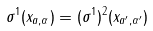<formula> <loc_0><loc_0><loc_500><loc_500>\sigma ^ { 1 } ( x _ { a , \alpha } ) = ( \sigma ^ { 1 } ) ^ { 2 } ( x _ { a ^ { \prime } , \alpha ^ { \prime } } )</formula> 